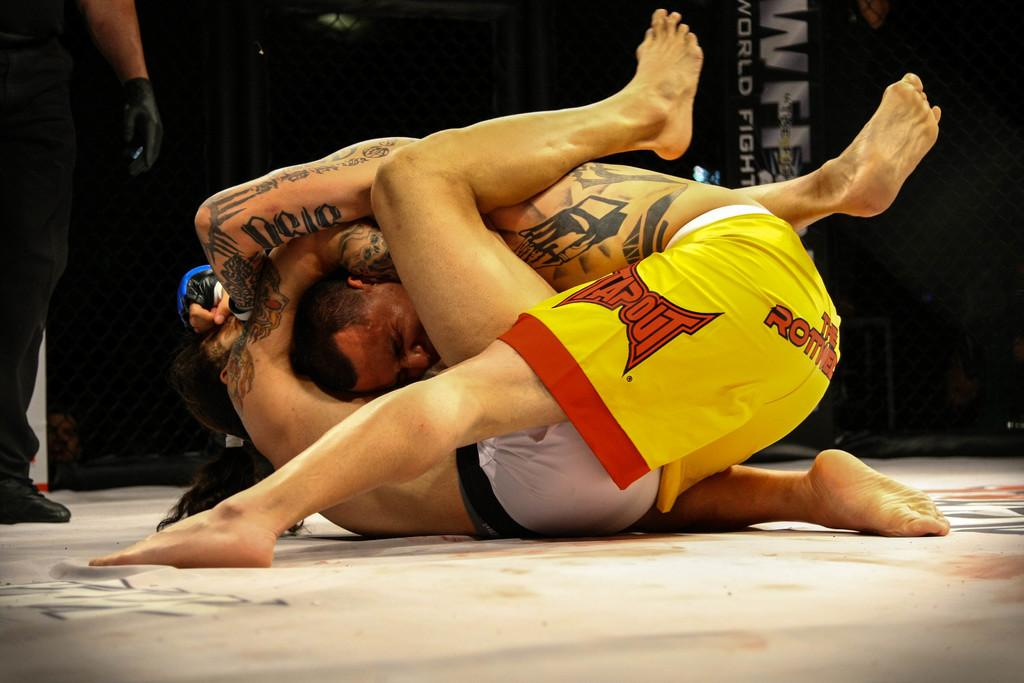What are the two men in the foreground of the image doing? The two men are wrestling in the foreground of the image. What is the color of the surface they are wrestling on? The surface they are wrestling on is white. Can you describe the man on the left side of the image? There is a man standing on the left side of the image. What can be seen in the background of the image? In the background, there is some text visible in a dark area. What type of island can be seen in the background of the image? There is no island visible in the image; the background features text in a dark area. What country are the men in the image from? The provided facts do not mention the country of origin for the men in the image. 